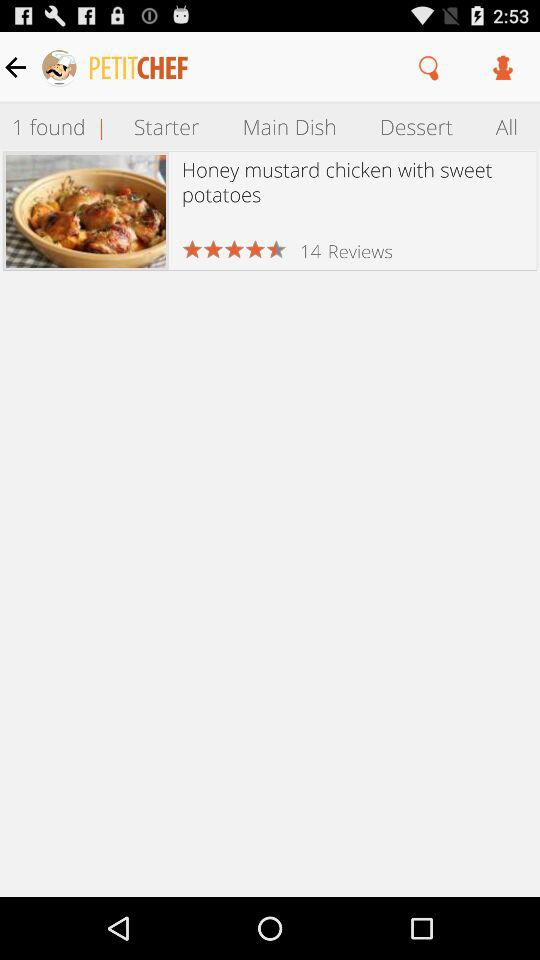How many reviews does the dish have?
Answer the question using a single word or phrase. 14 